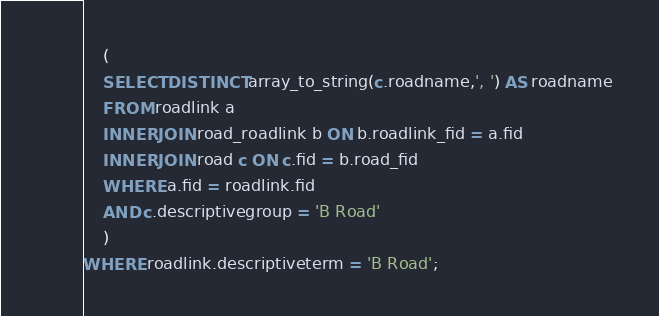<code> <loc_0><loc_0><loc_500><loc_500><_SQL_>	(
	SELECT DISTINCT array_to_string(c.roadname,', ') AS roadname 
	FROM roadlink a 
	INNER JOIN road_roadlink b ON b.roadlink_fid = a.fid
	INNER JOIN road c ON c.fid = b.road_fid
	WHERE a.fid = roadlink.fid 
	AND c.descriptivegroup = 'B Road'
	)
WHERE roadlink.descriptiveterm = 'B Road';
</code> 